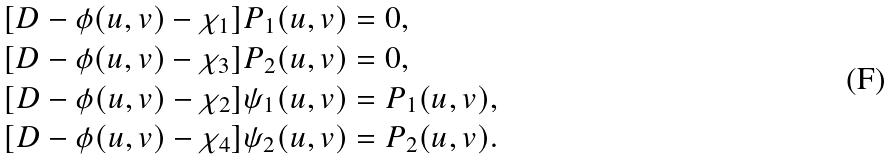<formula> <loc_0><loc_0><loc_500><loc_500>[ D - \phi ( u , v ) - \chi _ { 1 } ] P _ { 1 } ( u , v ) & = 0 , \\ [ D - \phi ( u , v ) - \chi _ { 3 } ] P _ { 2 } ( u , v ) & = 0 , \\ [ D - \phi ( u , v ) - \chi _ { 2 } ] \psi _ { 1 } ( u , v ) & = P _ { 1 } ( u , v ) , \\ [ D - \phi ( u , v ) - \chi _ { 4 } ] \psi _ { 2 } ( u , v ) & = P _ { 2 } ( u , v ) .</formula> 